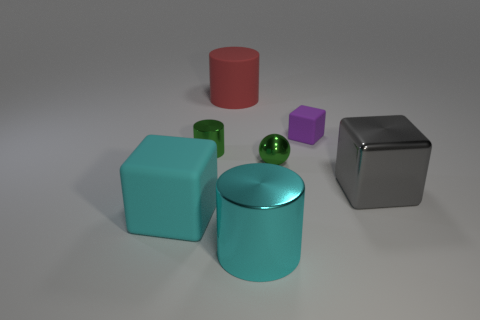Does the metallic block have the same size as the cyan metal object?
Your response must be concise. Yes. What number of things are either big things to the right of the big red thing or tiny purple cylinders?
Provide a short and direct response. 2. There is a big cylinder that is behind the rubber block that is left of the big cyan metal cylinder; what is it made of?
Your answer should be very brief. Rubber. Are there any other things of the same shape as the red matte object?
Your answer should be compact. Yes. There is a purple rubber object; does it have the same size as the green shiny thing to the left of the green ball?
Give a very brief answer. Yes. How many things are cyan cylinders that are in front of the small cylinder or things on the left side of the big cyan cylinder?
Provide a short and direct response. 4. Are there more objects to the right of the cyan rubber cube than tiny objects?
Your answer should be compact. Yes. How many other matte cubes have the same size as the purple block?
Your response must be concise. 0. Does the red matte thing that is to the left of the shiny cube have the same size as the block in front of the gray metallic object?
Your answer should be compact. Yes. How big is the cube on the left side of the tiny metal sphere?
Give a very brief answer. Large. 